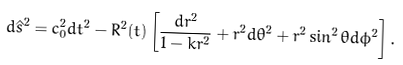<formula> <loc_0><loc_0><loc_500><loc_500>d { \hat { s } } ^ { 2 } = c _ { 0 } ^ { 2 } d t ^ { 2 } - R ^ { 2 } ( t ) \left [ \frac { d r ^ { 2 } } { 1 - k r ^ { 2 } } + r ^ { 2 } d \theta ^ { 2 } + r ^ { 2 } \sin ^ { 2 } \theta d \phi ^ { 2 } \right ] .</formula> 